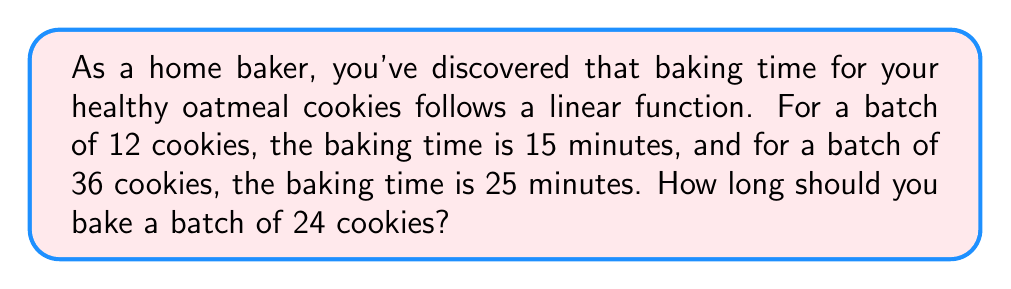Teach me how to tackle this problem. Let's approach this step-by-step:

1) First, we need to find the linear function that relates the number of cookies to the baking time. We can represent this function as:

   $T = mx + b$

   Where $T$ is the baking time, $x$ is the number of cookies, $m$ is the slope, and $b$ is the y-intercept.

2) We have two points to work with:
   (12, 15) and (36, 25)

3) We can find the slope using the slope formula:

   $m = \frac{y_2 - y_1}{x_2 - x_1} = \frac{25 - 15}{36 - 12} = \frac{10}{24} = \frac{5}{12}$

4) Now we can use either point to find $b$. Let's use (12, 15):

   $15 = \frac{5}{12}(12) + b$
   $15 = 5 + b$
   $b = 10$

5) So our linear function is:

   $T = \frac{5}{12}x + 10$

6) To find the baking time for 24 cookies, we substitute $x = 24$:

   $T = \frac{5}{12}(24) + 10$
   $T = 10 + 10 = 20$

Therefore, a batch of 24 cookies should be baked for 20 minutes.
Answer: 20 minutes 